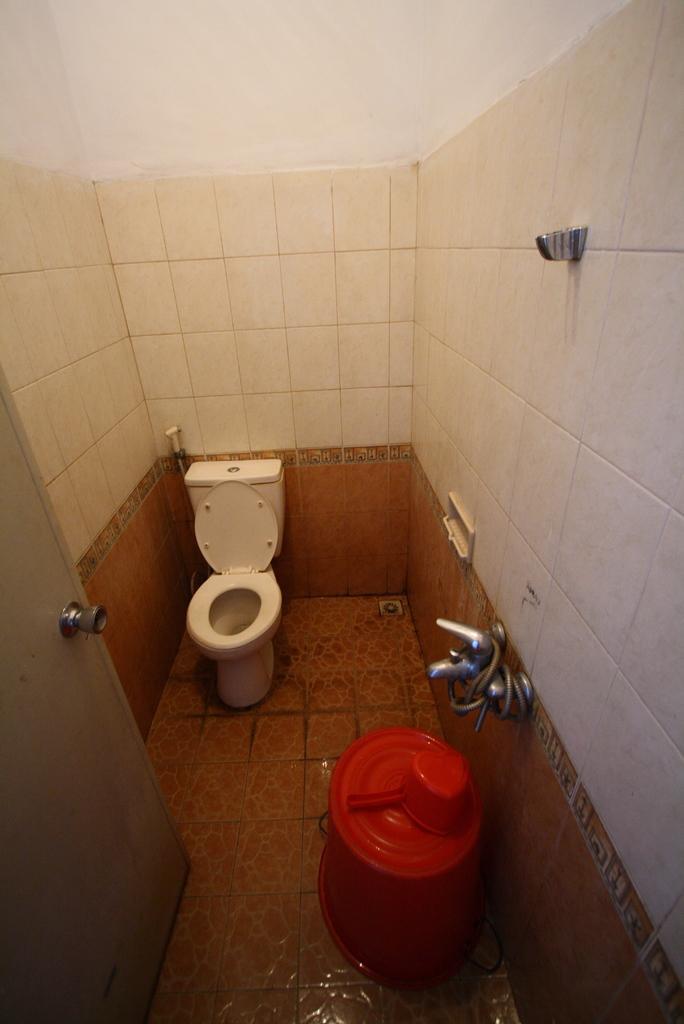Could you give a brief overview of what you see in this image? This image is taken in the bathroom and here we can see a bucket, mug, tap, a pipe and there is toilet, a door and there is a wall. At the bottom, there is a floor. 